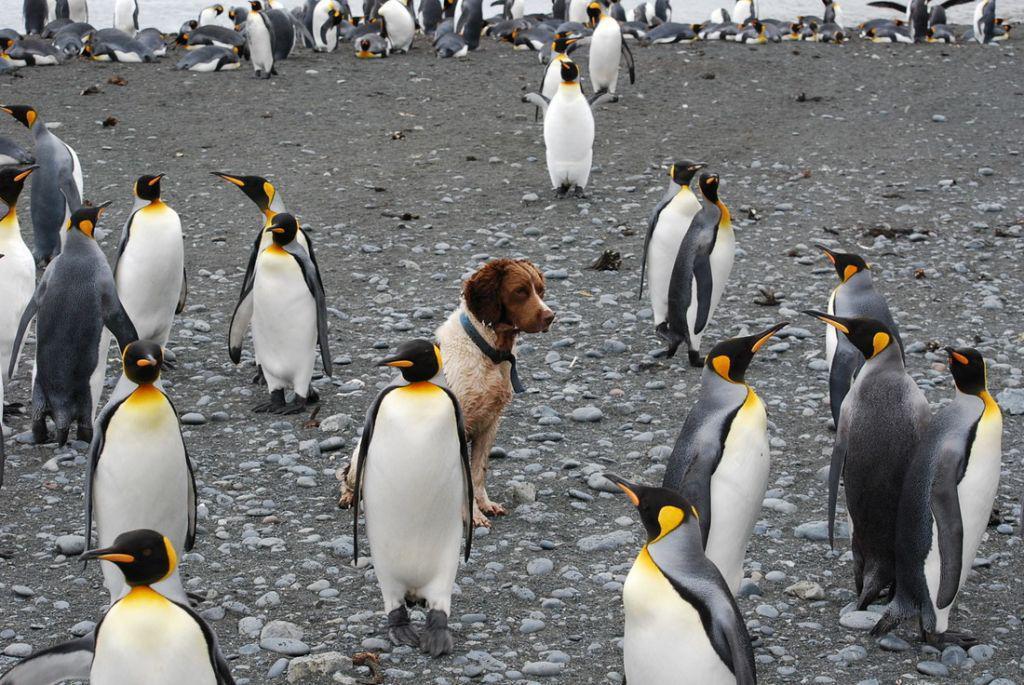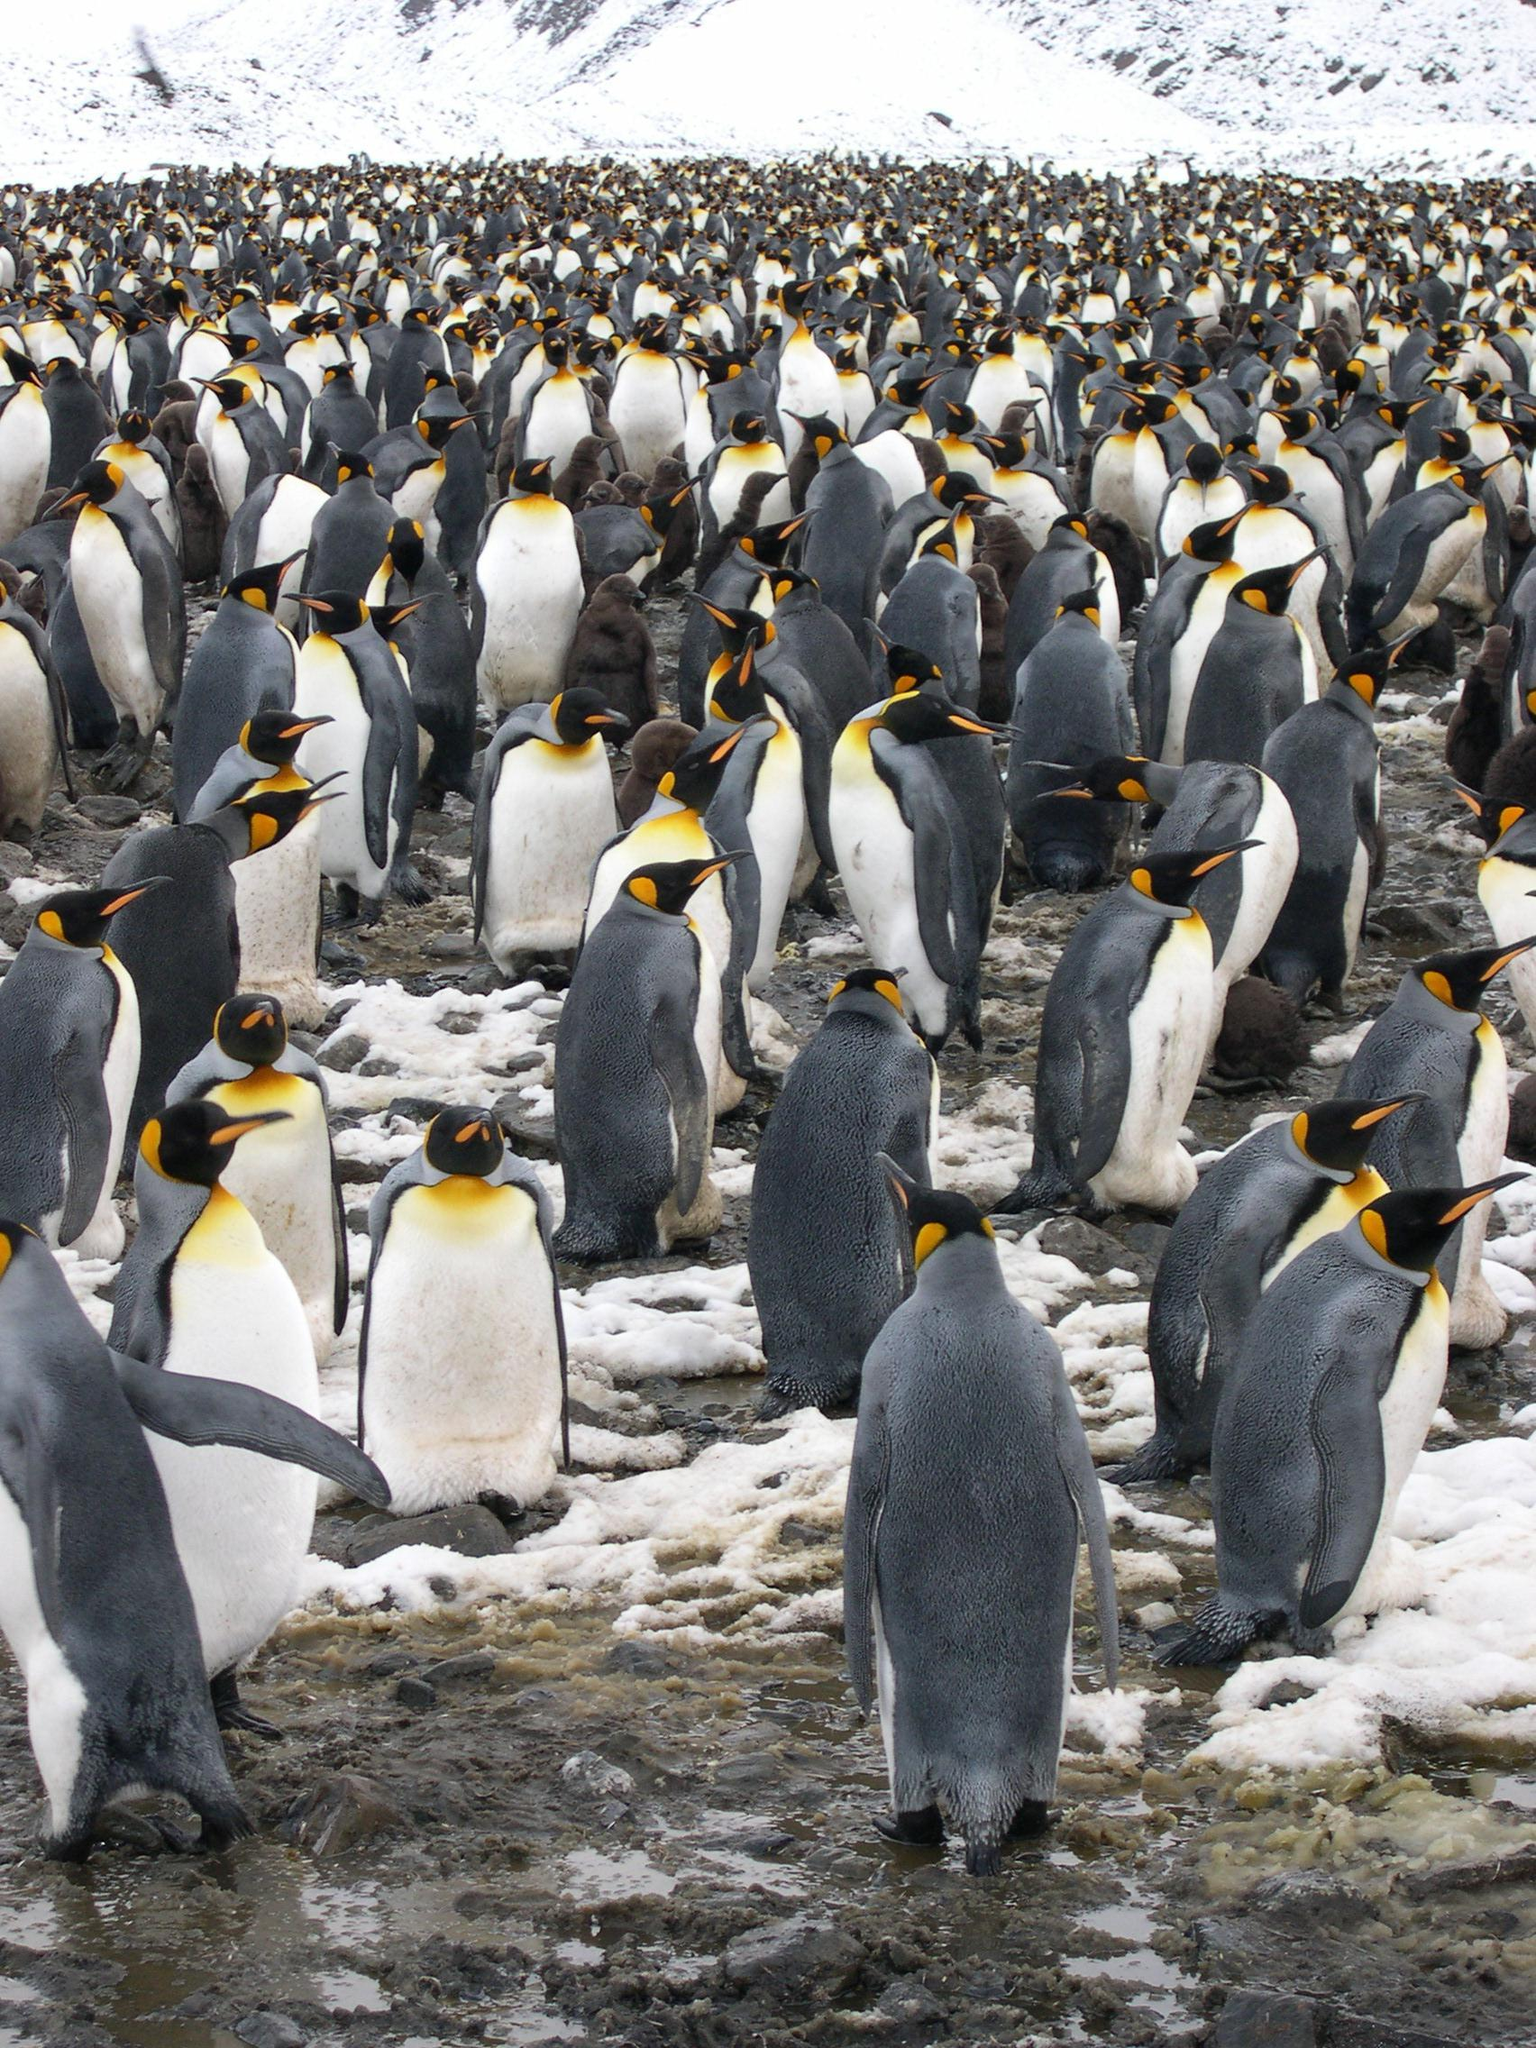The first image is the image on the left, the second image is the image on the right. For the images displayed, is the sentence "One of the images shows at least one brown fluffy penguin near the black and white penguins." factually correct? Answer yes or no. No. 